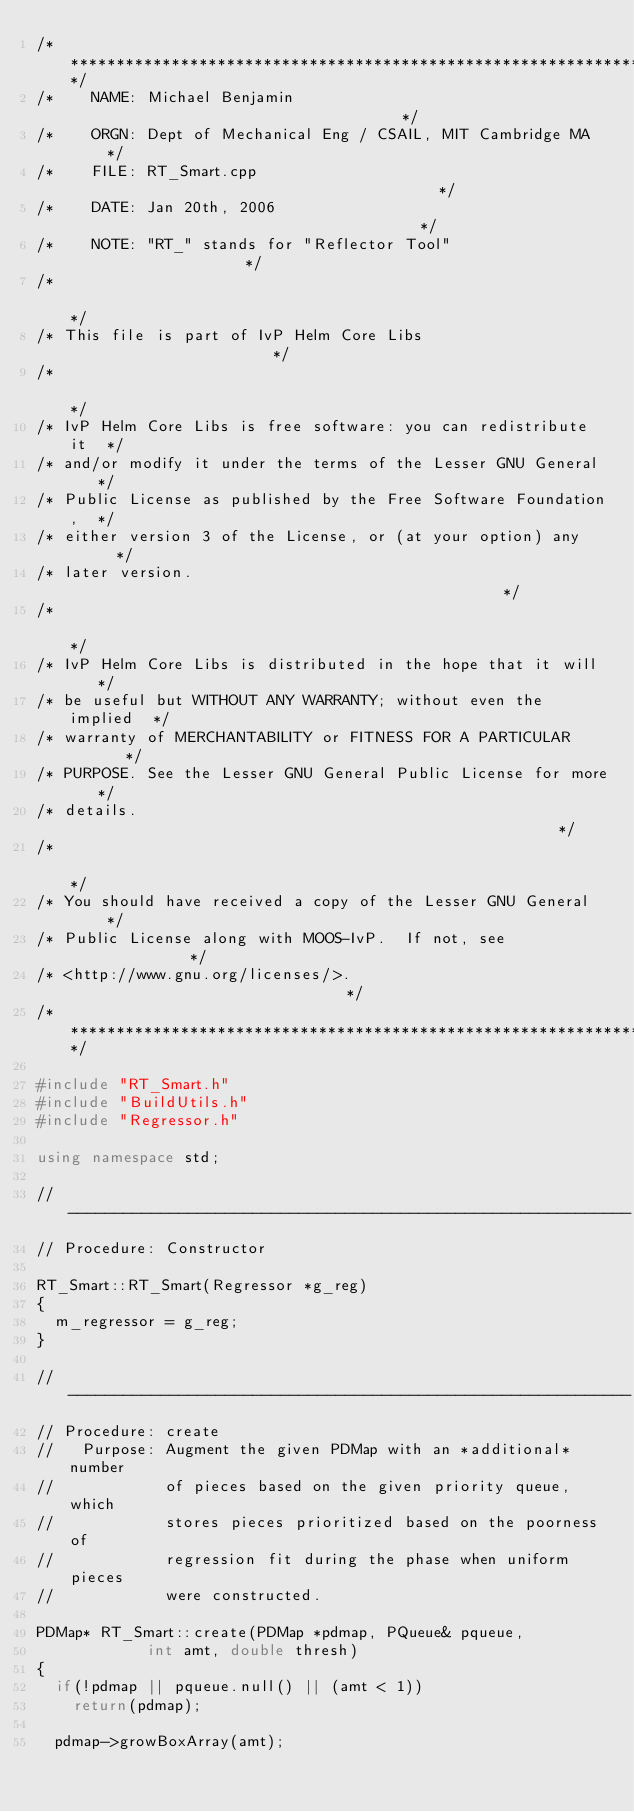<code> <loc_0><loc_0><loc_500><loc_500><_C++_>/*****************************************************************/
/*    NAME: Michael Benjamin                                     */
/*    ORGN: Dept of Mechanical Eng / CSAIL, MIT Cambridge MA     */
/*    FILE: RT_Smart.cpp                                         */
/*    DATE: Jan 20th, 2006                                       */
/*    NOTE: "RT_" stands for "Reflector Tool"                    */
/*                                                               */
/* This file is part of IvP Helm Core Libs                       */
/*                                                               */
/* IvP Helm Core Libs is free software: you can redistribute it  */
/* and/or modify it under the terms of the Lesser GNU General    */
/* Public License as published by the Free Software Foundation,  */
/* either version 3 of the License, or (at your option) any      */
/* later version.                                                */
/*                                                               */
/* IvP Helm Core Libs is distributed in the hope that it will    */
/* be useful but WITHOUT ANY WARRANTY; without even the implied  */
/* warranty of MERCHANTABILITY or FITNESS FOR A PARTICULAR       */
/* PURPOSE. See the Lesser GNU General Public License for more   */
/* details.                                                      */
/*                                                               */
/* You should have received a copy of the Lesser GNU General     */
/* Public License along with MOOS-IvP.  If not, see              */
/* <http://www.gnu.org/licenses/>.                               */
/*****************************************************************/

#include "RT_Smart.h"
#include "BuildUtils.h"
#include "Regressor.h"

using namespace std;

//-------------------------------------------------------------
// Procedure: Constructor

RT_Smart::RT_Smart(Regressor *g_reg) 
{
  m_regressor = g_reg;
}

//-------------------------------------------------------------
// Procedure: create
//   Purpose: Augment the given PDMap with an *additional* number
//            of pieces based on the given priority queue, which 
//            stores pieces prioritized based on the poorness of
//            regression fit during the phase when uniform pieces
//            were constructed.

PDMap* RT_Smart::create(PDMap *pdmap, PQueue& pqueue, 
			int amt, double thresh)
{
  if(!pdmap || pqueue.null() || (amt < 1))
    return(pdmap);

  pdmap->growBoxArray(amt);</code> 